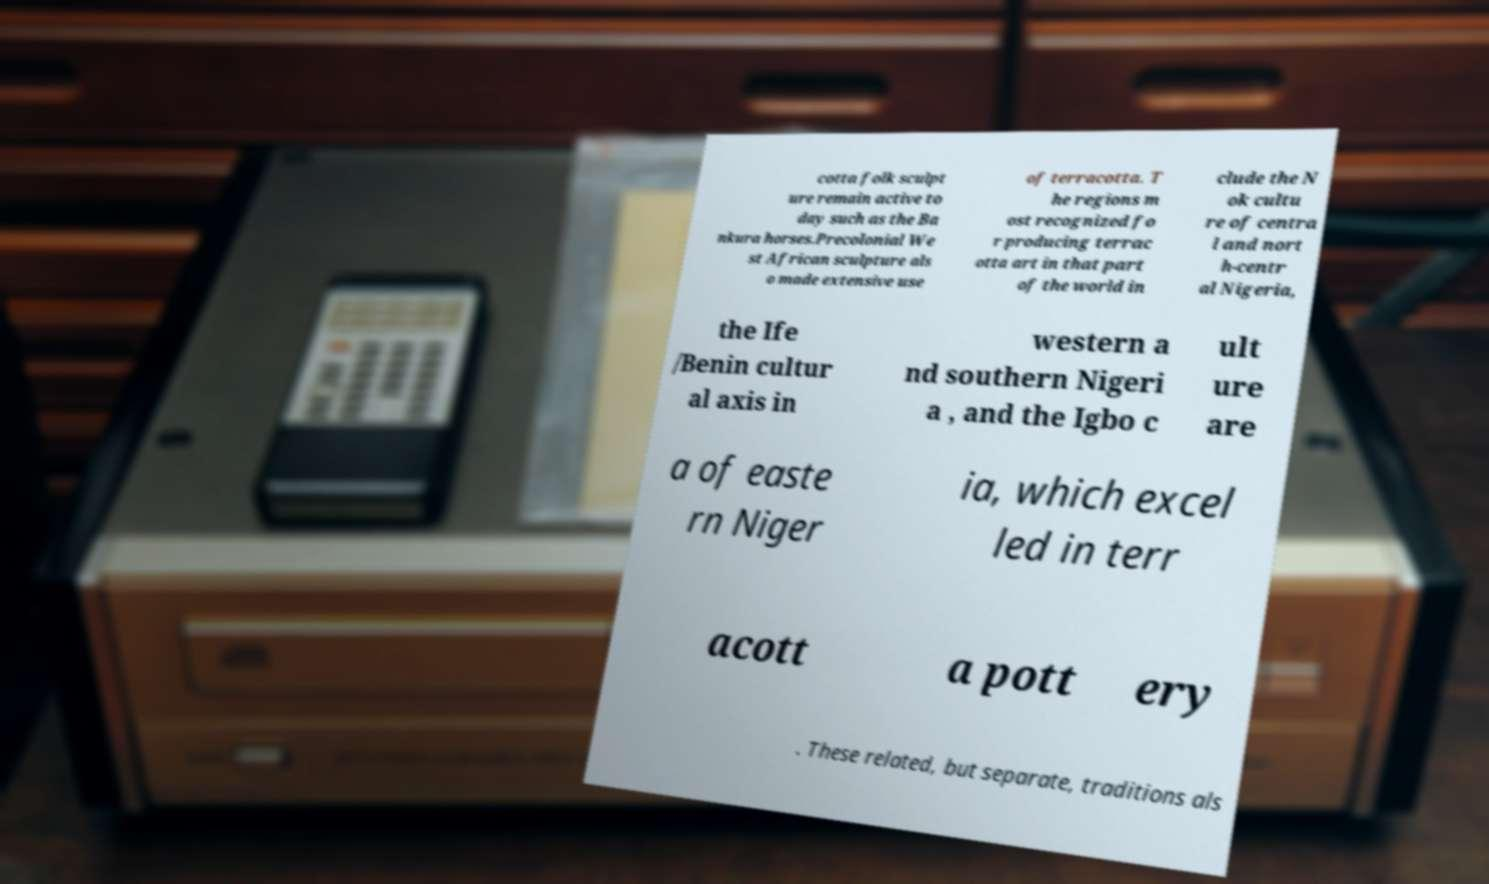There's text embedded in this image that I need extracted. Can you transcribe it verbatim? cotta folk sculpt ure remain active to day such as the Ba nkura horses.Precolonial We st African sculpture als o made extensive use of terracotta. T he regions m ost recognized fo r producing terrac otta art in that part of the world in clude the N ok cultu re of centra l and nort h-centr al Nigeria, the Ife /Benin cultur al axis in western a nd southern Nigeri a , and the Igbo c ult ure are a of easte rn Niger ia, which excel led in terr acott a pott ery . These related, but separate, traditions als 